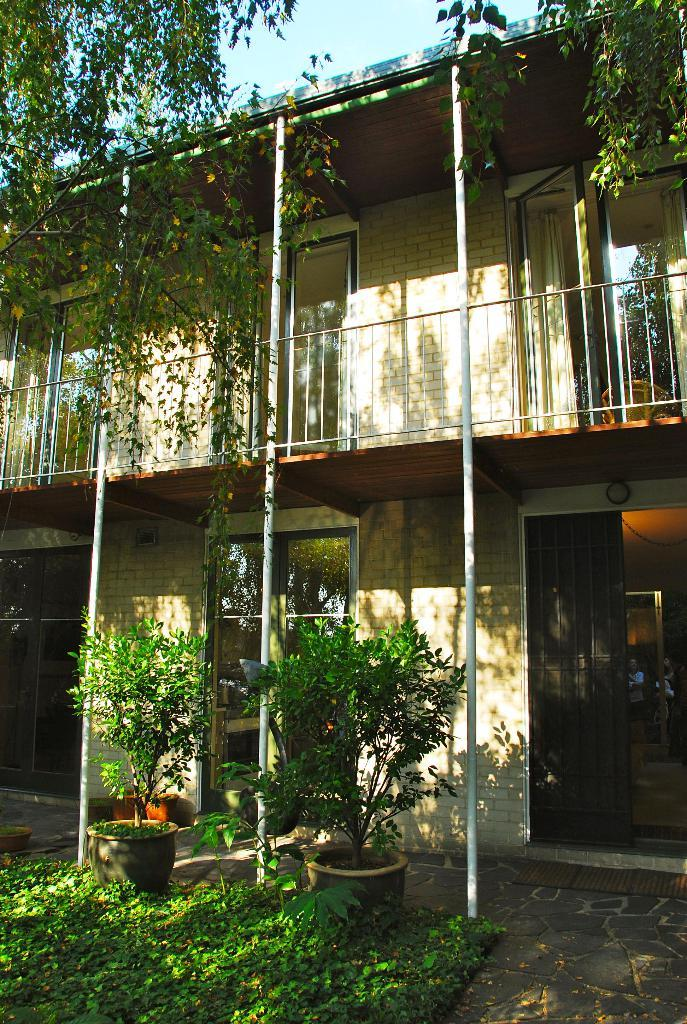What type of vegetation can be seen in the image? There are trees in the image. What type of structure is present in the image? There is a building in the image. What type of indoor plants are visible in the image? There are house plants in the image. What is visible in the background of the image? The sky is visible in the image. How many hens are participating in the competition in the image? There are no hens or competitions present in the image. What shape is the square house in the image? There is no square house in the image; the building is not described as having a square shape. 